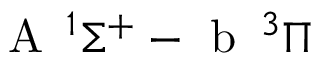Convert formula to latex. <formula><loc_0><loc_0><loc_500><loc_500>A \, ^ { 1 } \Sigma ^ { + } - b \, ^ { 3 } \Pi</formula> 